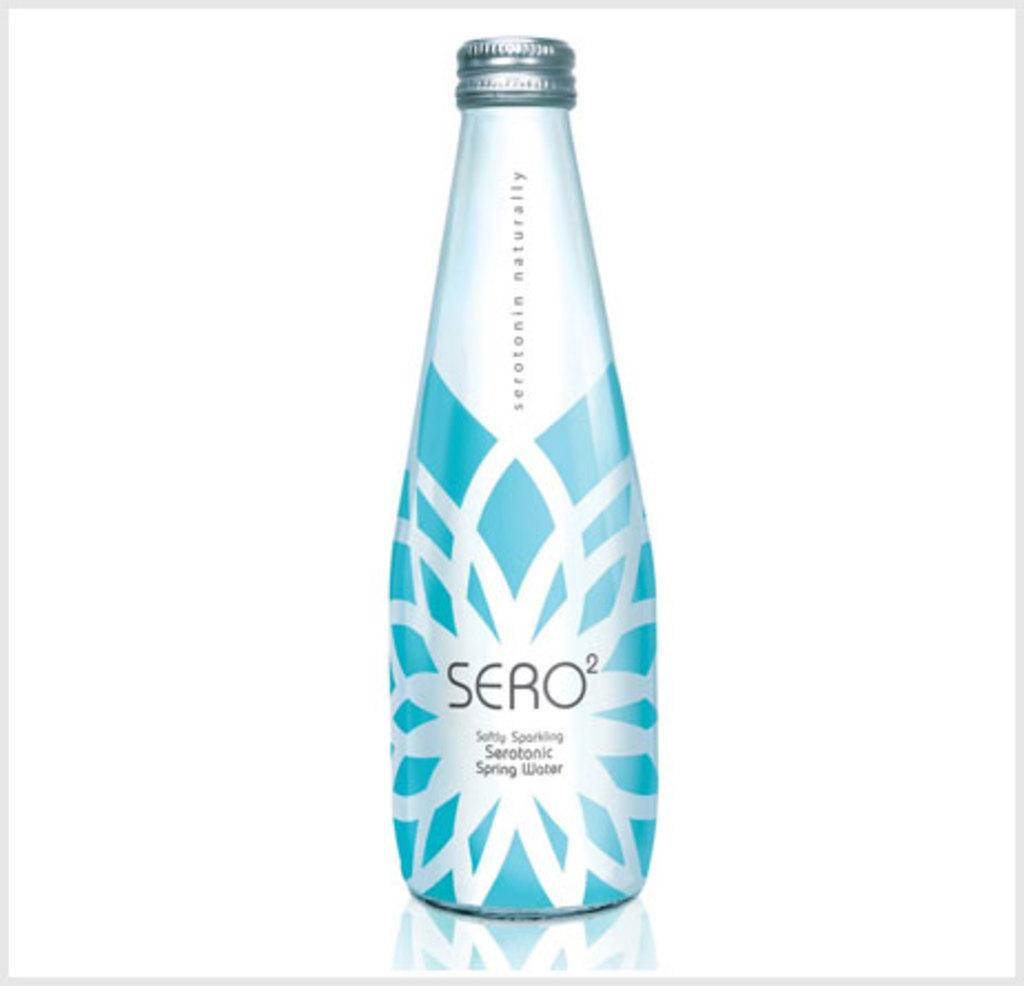<image>
Write a terse but informative summary of the picture. A blue and white bottle of Sero spring water. 